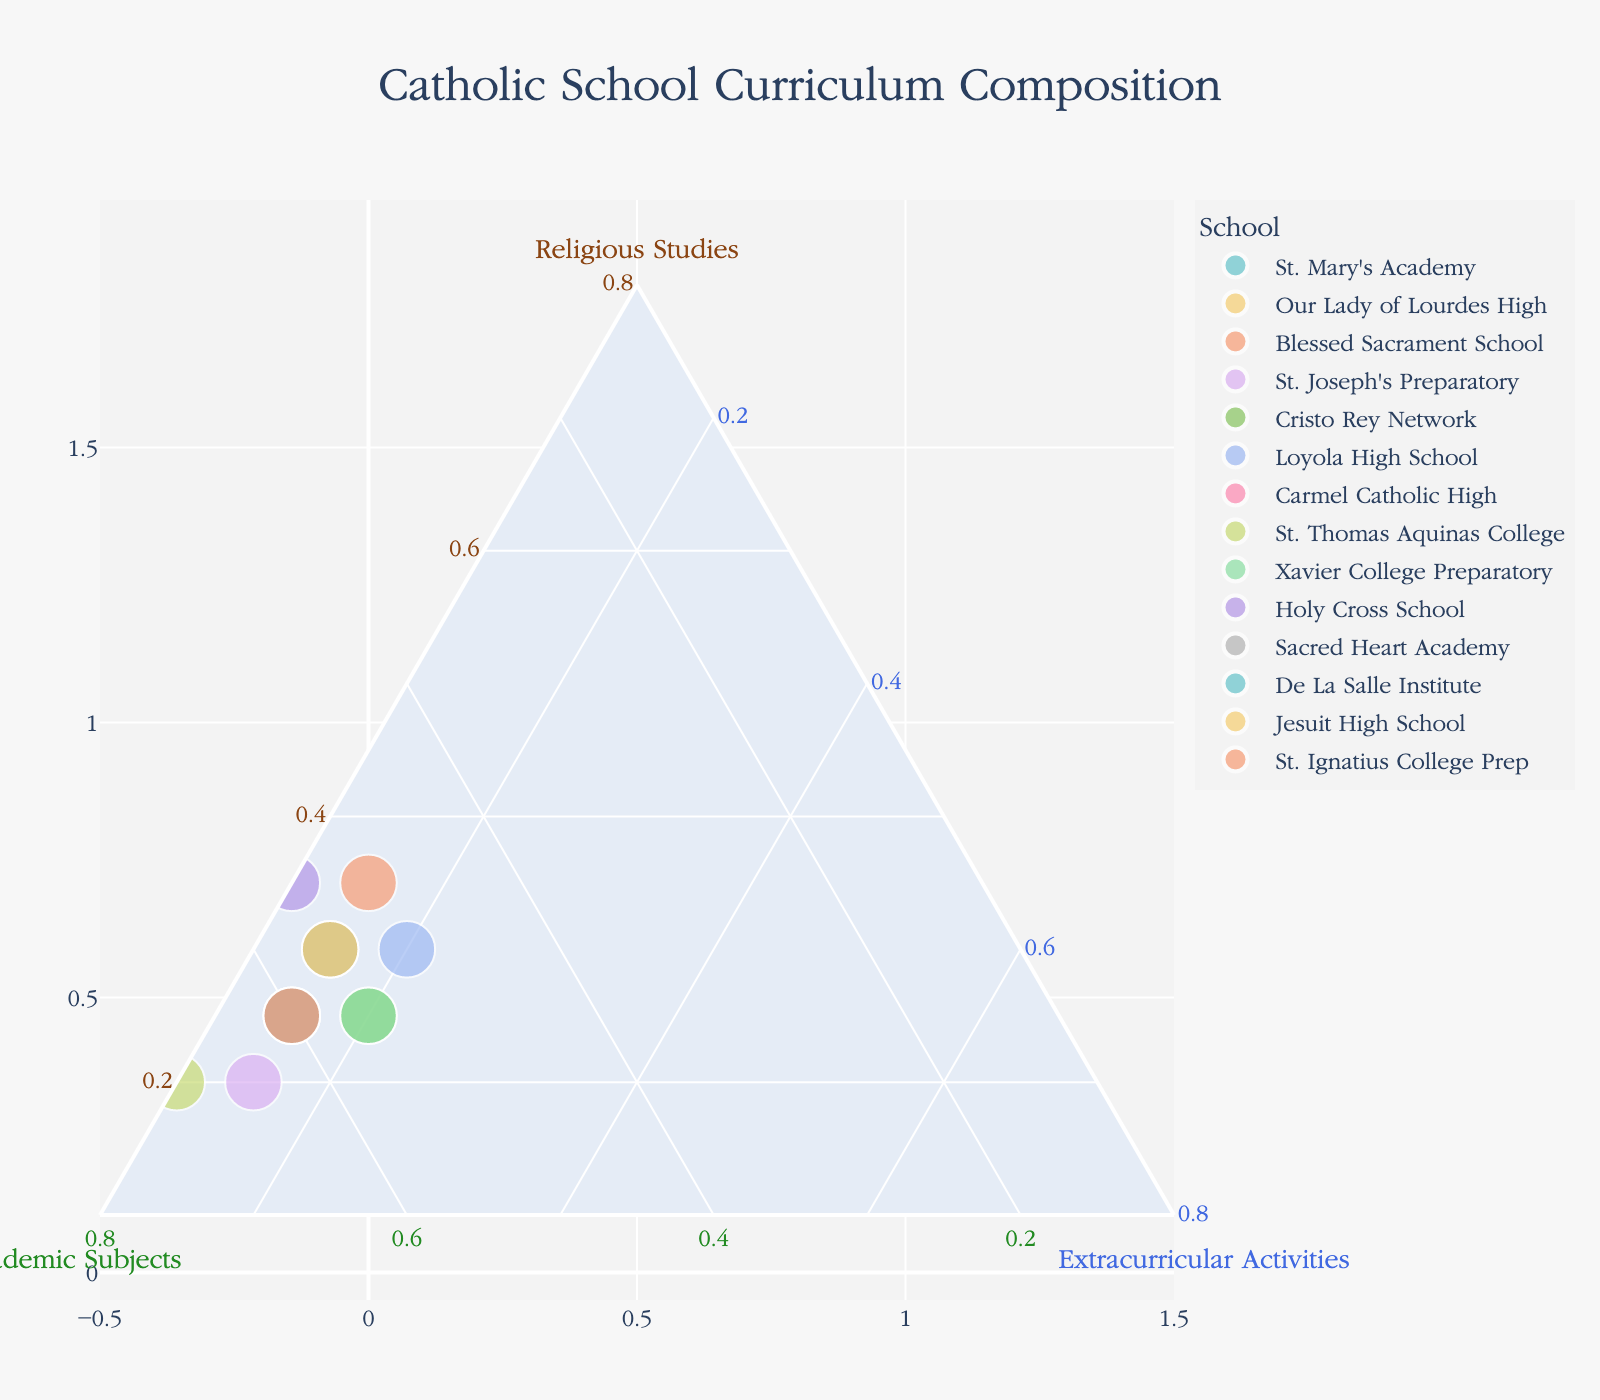What are the three categories represented on the ternary plot? The ternary plot represents three categories: Religious Studies, Academic Subjects, and Extracurricular Activities. These categories are indicated by the titles on the three axes of the plot.
Answer: Religious Studies, Academic Subjects, Extracurricular Activities Which school has the highest percentage of Religious Studies? By observing the points closest to the Religious Studies axis, we can see that Blessed Sacrament School and Holy Cross School both have the highest percentage of Religious Studies.
Answer: Blessed Sacrament School, Holy Cross School How does the percentage of Academic Subjects compare between St. Joseph's Preparatory and St. Thomas Aquinas College? St. Thomas Aquinas College allocates 70% to Academic Subjects, which is higher than St. Joseph's Preparatory's 65%. This can be seen by looking at the positioning relative to the Academic Subjects axis.
Answer: St. Thomas Aquinas College has more What is the combined percentage of Religious Studies and Extracurricular Activities for Cristo Rey Network? Cristo Rey Network has 25% for Religious Studies and 20% for Extracurricular Activities. Adding these together gives 25 + 20 = 45%.
Answer: 45% Which school allocates the smallest percentage to Extracurricular Activities? By looking at the schools closest to the Academic Subjects and Religious Studies axes, St. Thomas Aquinas College and Holy Cross School allocate the smallest percentage to Extracurricular Activities with just 10%.
Answer: St. Thomas Aquinas College, Holy Cross School Are there any schools with an equal distribution between Academic Subjects and Religious Studies? No school has equal percentages of Academic Subjects and Religious Studies; all schools show a difference between these two categories.
Answer: No How many schools allocate exactly 15% to Extracurricular Activities? By counting the data points positioned at the same distance from the Extracurricular Activities axis, we can see there are nine schools: St. Mary's Academy, Our Lady of Lourdes High, Blessed Sacrament School, St. Joseph's Preparatory, Carmel Catholic High, Sacred Heart Academy, De La Salle Institute, Jesuit High School, and St. Ignatius College Prep.
Answer: Nine schools Which school has a more balanced curriculum across all three categories? Cristo Rey Network and Xavier College Preparatory have relatively balanced distribution with percentages of 25-55-20 and 25-55-20 respectively. These values show a more even spread compared to others.
Answer: Cristo Rey Network, Xavier College Preparatory What is the range of Academic Subjects percentages among the schools? The highest percentage for Academic Subjects is 70% (St. Thomas Aquinas College) and the lowest is 50% (Blessed Sacrament School, Loyola High School), giving a range of 70 - 50 = 20%.
Answer: 20% Which school appears to focus the most on Academic Subjects while still allocating at least 10% to Religious Studies and Extracurricular Activities? St. Thomas Aquinas College allocates 70% to Academic Subjects, while still meeting at least the 10% allocation for the other two categories (20% for Religious Studies and 10% for Extracurricular Activities).
Answer: St. Thomas Aquinas College 